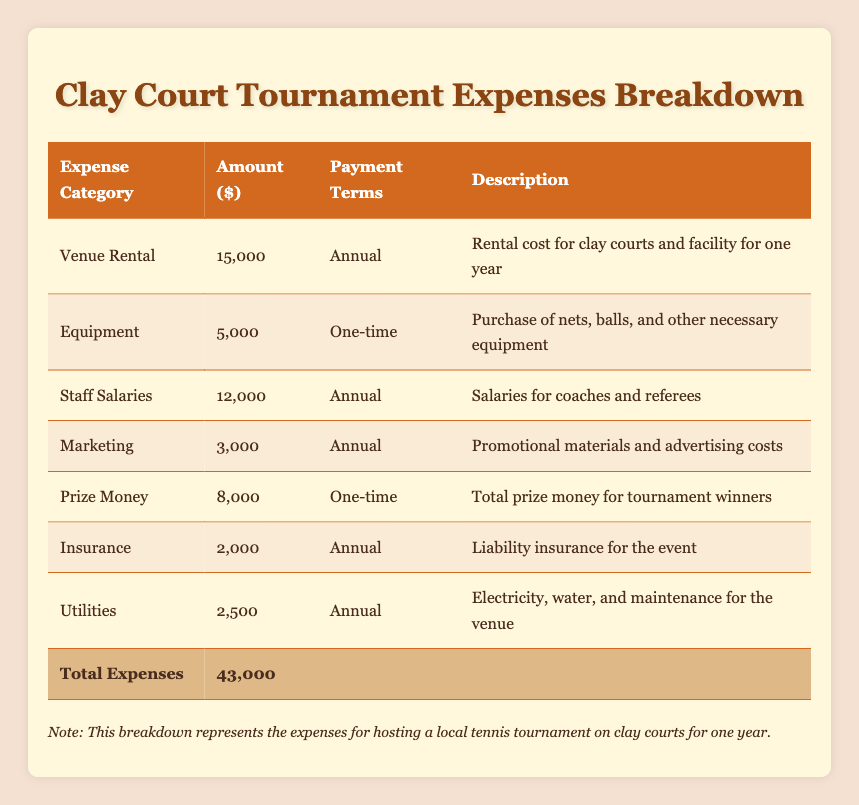What is the total amount allocated for venue rental? The table states the amount for venue rental is 15,000. To answer the question, we simply look at the 'Venue Rental' row in the table for the specific amount.
Answer: 15,000 How much is spent on marketing? According to the table, the marketing costs are shown as 3,000. This information is directly found in the 'Marketing' row.
Answer: 3,000 Is the prize money a one-time payment? The table indicates that the prize money is categorized under 'one-time' payment terms. Therefore, it confirms that it is indeed a one-time payment.
Answer: Yes What are the total annual expenses without the one-time payments? To find the total annual expenses excluding one-time payments, we need to sum the amounts of annual payments: 15,000 for venue rental, 12,000 for staff salaries, 3,000 for marketing, 2,000 for insurance, and 2,500 for utilities. Adding these together gives 34,500.
Answer: 34,500 How much more is spent on staff salaries compared to utilities? From the table, staff salaries are 12,000 and utilities are 2,500. The difference can be calculated as 12,000 - 2,500 = 9,500, indicating staff salaries exceed utilities by this amount.
Answer: 9,500 What percentage of the total expenses is the equipment cost? The equipment cost is given as 5,000, while the total expenses are 43,000. To find the percentage, divide 5,000 by 43,000 and multiply by 100, resulting in approximately 11.63%.
Answer: Approximately 11.63% Are the insurance costs lower than the equipment costs? According to the table, insurance costs are 2,000 while equipment costs are 5,000. Comparing the two amounts shows that 2,000 is indeed less than 5,000.
Answer: Yes How much is spent on utility expenses compared to marketing expenses? Utilities cost 2,500 and marketing costs 3,000, so we subtract the utility expenses from marketing: 3,000 - 2,500 = 500. Thus, marketing expenses are 500 more than utility expenses.
Answer: 500 If the tournament had to cut 10% from the total expenses, how much would that be? The total expenses are 43,000, and calculating 10% of this amount involves multiplying by 0.10: 43,000 * 0.10 = 4,300. Therefore, if 10% were cut, it would amount to 4,300.
Answer: 4,300 